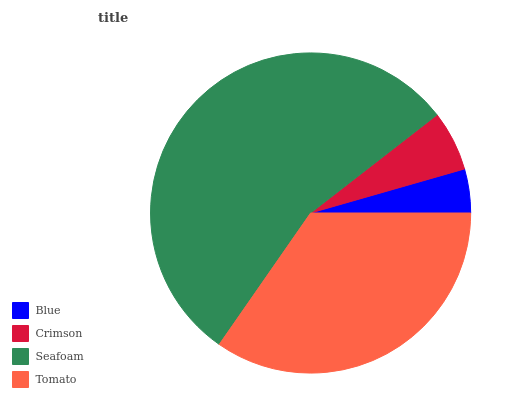Is Blue the minimum?
Answer yes or no. Yes. Is Seafoam the maximum?
Answer yes or no. Yes. Is Crimson the minimum?
Answer yes or no. No. Is Crimson the maximum?
Answer yes or no. No. Is Crimson greater than Blue?
Answer yes or no. Yes. Is Blue less than Crimson?
Answer yes or no. Yes. Is Blue greater than Crimson?
Answer yes or no. No. Is Crimson less than Blue?
Answer yes or no. No. Is Tomato the high median?
Answer yes or no. Yes. Is Crimson the low median?
Answer yes or no. Yes. Is Seafoam the high median?
Answer yes or no. No. Is Blue the low median?
Answer yes or no. No. 